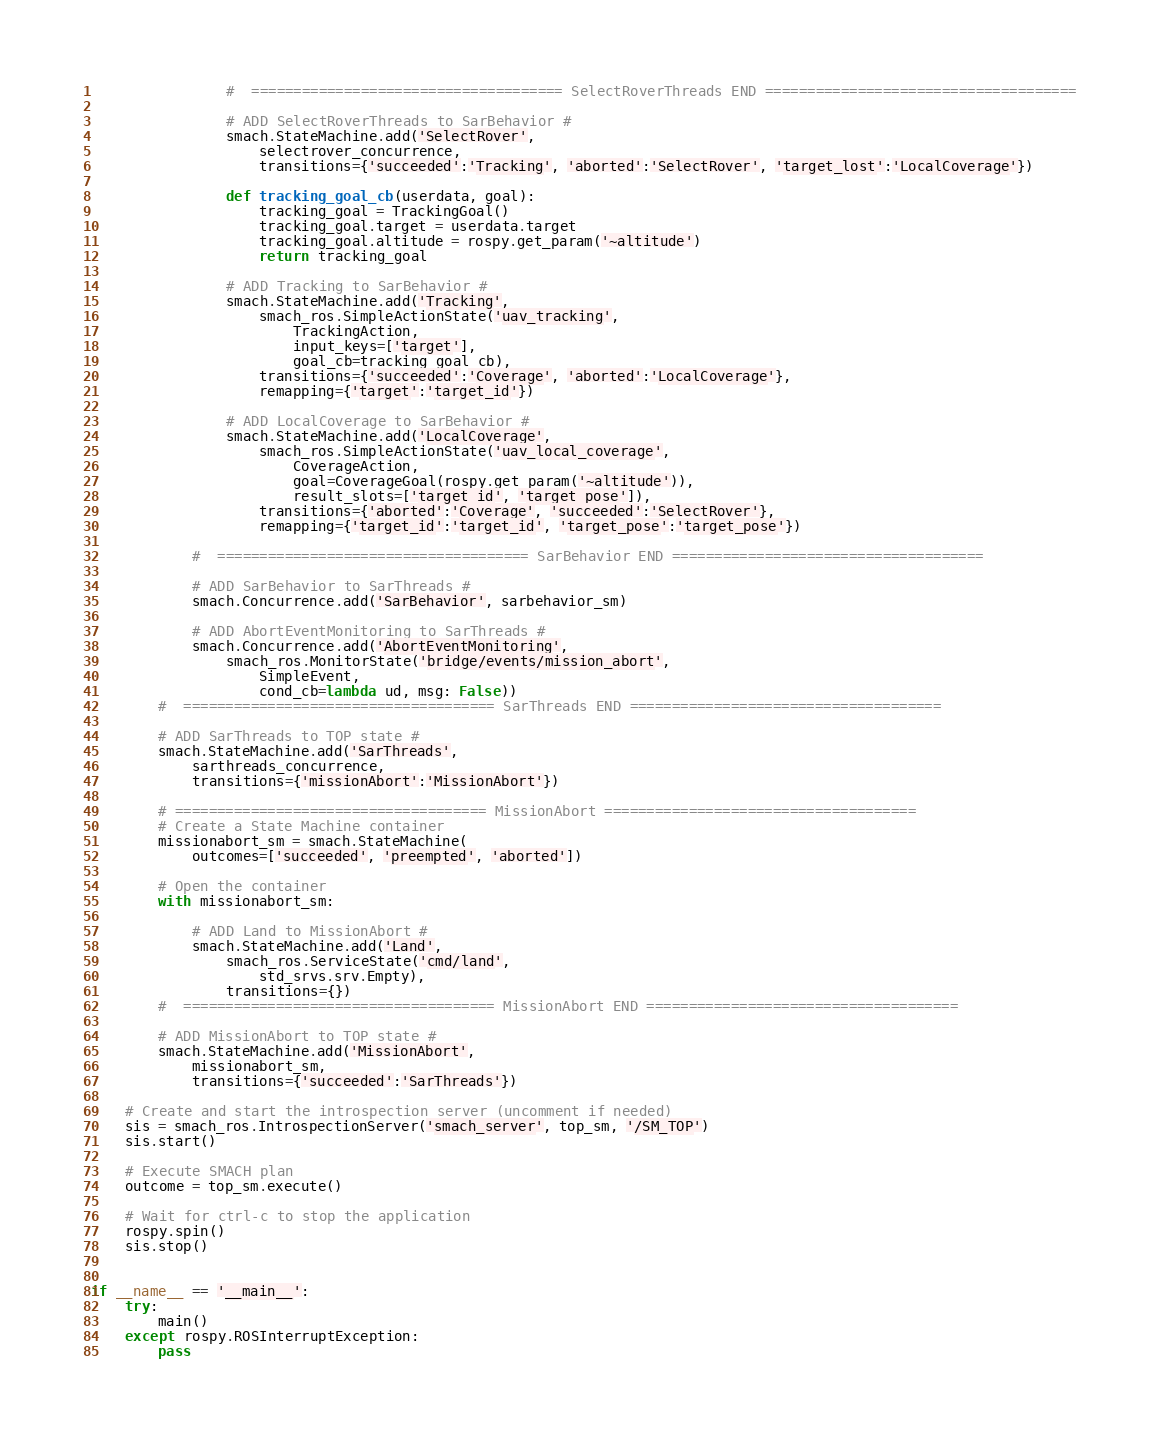Convert code to text. <code><loc_0><loc_0><loc_500><loc_500><_Python_>				#  ===================================== SelectRoverThreads END =====================================

				# ADD SelectRoverThreads to SarBehavior #
				smach.StateMachine.add('SelectRover',
					selectrover_concurrence,
					transitions={'succeeded':'Tracking', 'aborted':'SelectRover', 'target_lost':'LocalCoverage'})

				def tracking_goal_cb(userdata, goal):
					tracking_goal = TrackingGoal()
					tracking_goal.target = userdata.target
					tracking_goal.altitude = rospy.get_param('~altitude')
					return tracking_goal

				# ADD Tracking to SarBehavior #
				smach.StateMachine.add('Tracking',
					smach_ros.SimpleActionState('uav_tracking',
						TrackingAction,
						input_keys=['target'],
						goal_cb=tracking_goal_cb),
					transitions={'succeeded':'Coverage', 'aborted':'LocalCoverage'},
					remapping={'target':'target_id'})

				# ADD LocalCoverage to SarBehavior #
				smach.StateMachine.add('LocalCoverage',
					smach_ros.SimpleActionState('uav_local_coverage',
						CoverageAction,
						goal=CoverageGoal(rospy.get_param('~altitude')),
						result_slots=['target_id', 'target_pose']),
					transitions={'aborted':'Coverage', 'succeeded':'SelectRover'},
					remapping={'target_id':'target_id', 'target_pose':'target_pose'})

			#  ===================================== SarBehavior END =====================================

			# ADD SarBehavior to SarThreads #
			smach.Concurrence.add('SarBehavior', sarbehavior_sm)

			# ADD AbortEventMonitoring to SarThreads #
			smach.Concurrence.add('AbortEventMonitoring',
				smach_ros.MonitorState('bridge/events/mission_abort',
					SimpleEvent,
					cond_cb=lambda ud, msg: False))
		#  ===================================== SarThreads END =====================================

		# ADD SarThreads to TOP state #
		smach.StateMachine.add('SarThreads',
			sarthreads_concurrence,
			transitions={'missionAbort':'MissionAbort'})

		# ===================================== MissionAbort =====================================
		# Create a State Machine container
		missionabort_sm = smach.StateMachine(
			outcomes=['succeeded', 'preempted', 'aborted'])

		# Open the container
		with missionabort_sm:

			# ADD Land to MissionAbort #
			smach.StateMachine.add('Land',
				smach_ros.ServiceState('cmd/land',
					std_srvs.srv.Empty),
				transitions={})
		#  ===================================== MissionAbort END =====================================

		# ADD MissionAbort to TOP state #
		smach.StateMachine.add('MissionAbort',
			missionabort_sm,
			transitions={'succeeded':'SarThreads'})

	# Create and start the introspection server (uncomment if needed)
	sis = smach_ros.IntrospectionServer('smach_server', top_sm, '/SM_TOP')
	sis.start()

	# Execute SMACH plan
	outcome = top_sm.execute()

	# Wait for ctrl-c to stop the application
	rospy.spin()
	sis.stop()


if __name__ == '__main__':
	try:
		main()
	except rospy.ROSInterruptException:
		pass
</code> 